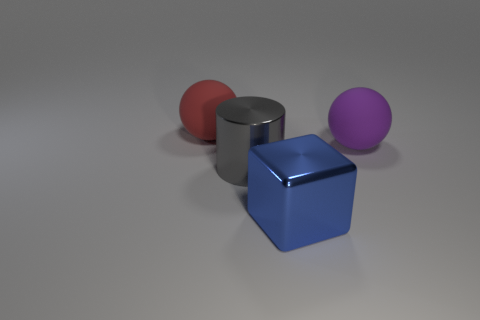Add 2 large cyan rubber cylinders. How many objects exist? 6 Subtract all cubes. How many objects are left? 3 Add 4 big cubes. How many big cubes exist? 5 Subtract 0 brown balls. How many objects are left? 4 Subtract all rubber things. Subtract all large metallic cylinders. How many objects are left? 1 Add 1 blue objects. How many blue objects are left? 2 